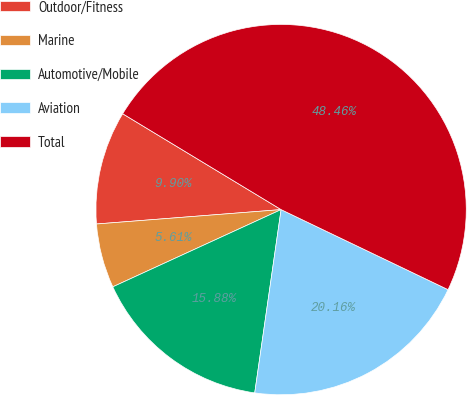Convert chart to OTSL. <chart><loc_0><loc_0><loc_500><loc_500><pie_chart><fcel>Outdoor/Fitness<fcel>Marine<fcel>Automotive/Mobile<fcel>Aviation<fcel>Total<nl><fcel>9.9%<fcel>5.61%<fcel>15.88%<fcel>20.16%<fcel>48.46%<nl></chart> 